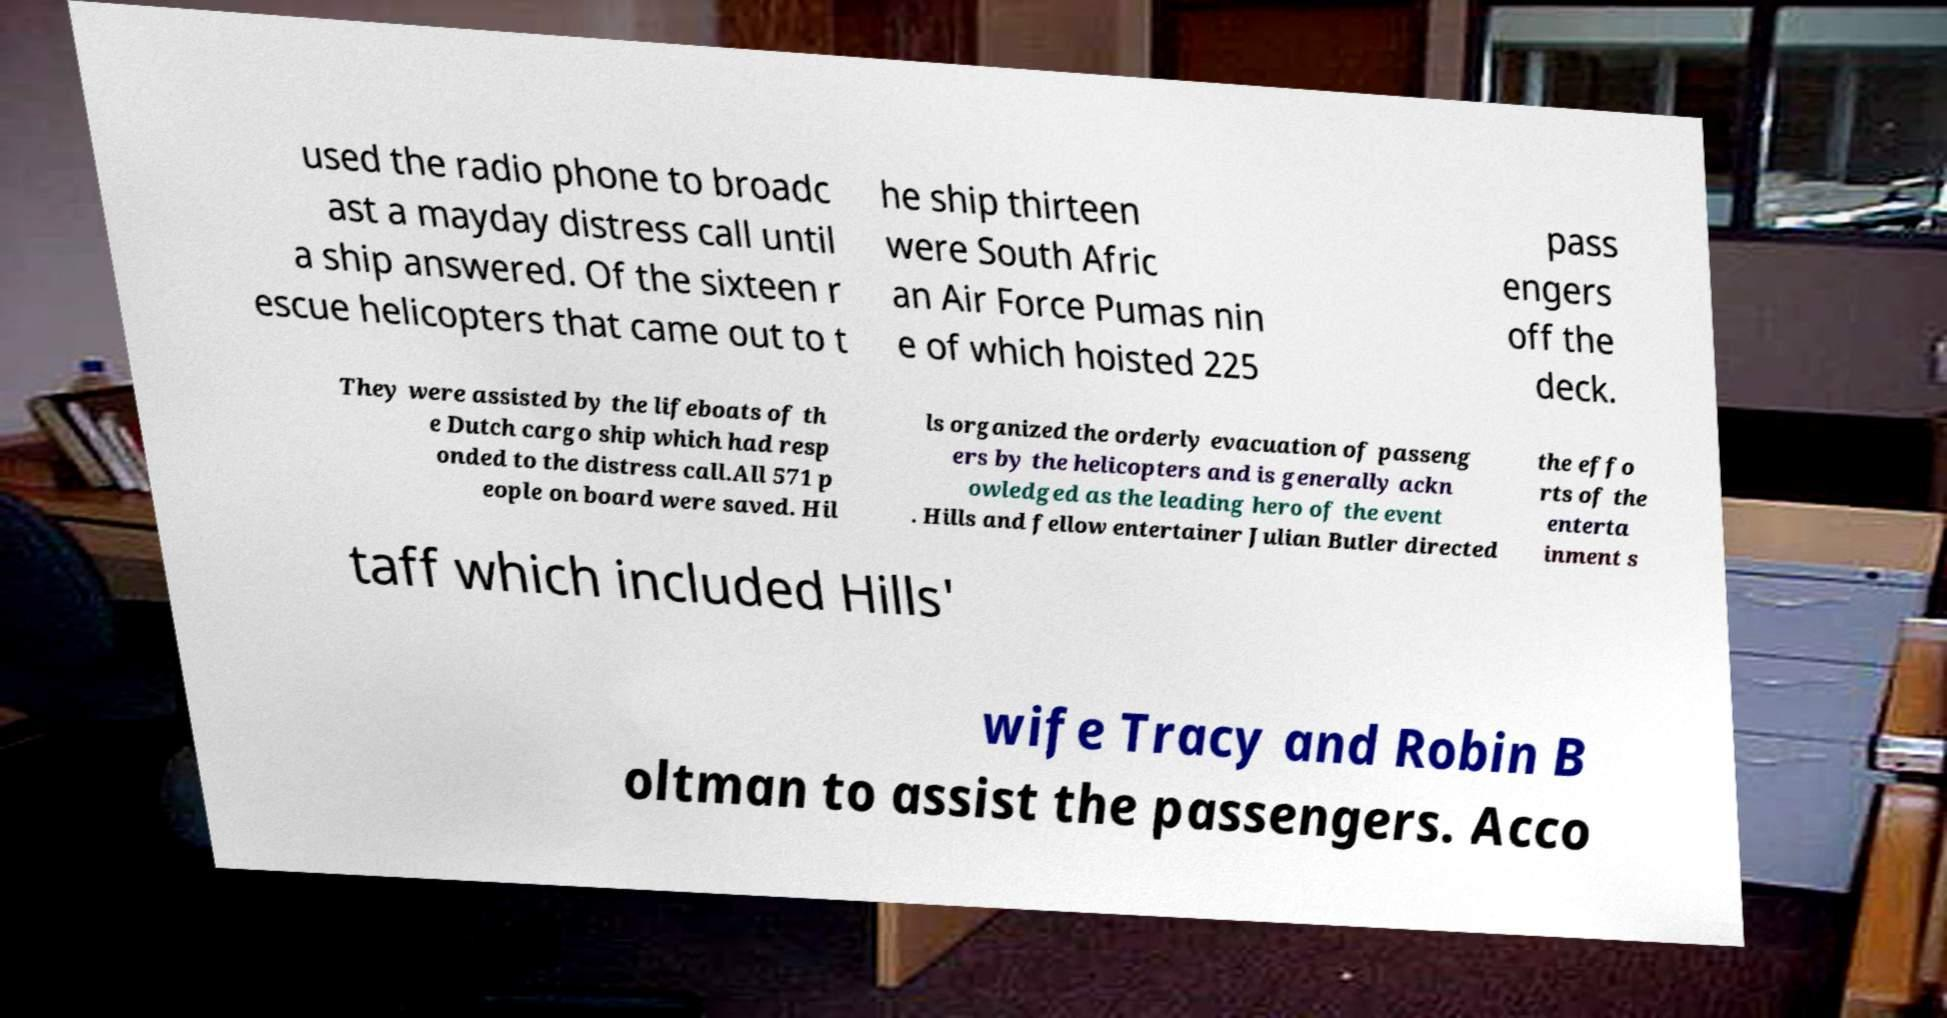There's text embedded in this image that I need extracted. Can you transcribe it verbatim? used the radio phone to broadc ast a mayday distress call until a ship answered. Of the sixteen r escue helicopters that came out to t he ship thirteen were South Afric an Air Force Pumas nin e of which hoisted 225 pass engers off the deck. They were assisted by the lifeboats of th e Dutch cargo ship which had resp onded to the distress call.All 571 p eople on board were saved. Hil ls organized the orderly evacuation of passeng ers by the helicopters and is generally ackn owledged as the leading hero of the event . Hills and fellow entertainer Julian Butler directed the effo rts of the enterta inment s taff which included Hills' wife Tracy and Robin B oltman to assist the passengers. Acco 